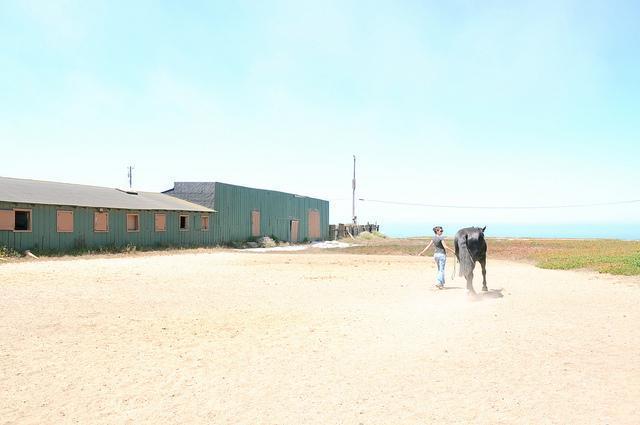How many trees are in the picture?
Give a very brief answer. 0. 